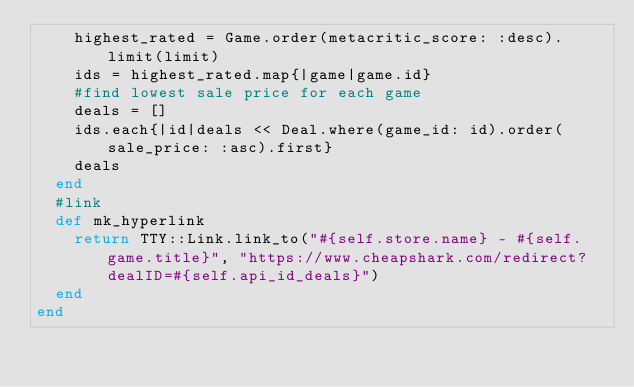Convert code to text. <code><loc_0><loc_0><loc_500><loc_500><_Ruby_>    highest_rated = Game.order(metacritic_score: :desc).limit(limit)
    ids = highest_rated.map{|game|game.id}    
    #find lowest sale price for each game
    deals = []
    ids.each{|id|deals << Deal.where(game_id: id).order(sale_price: :asc).first}  
    deals  
  end
  #link
  def mk_hyperlink
    return TTY::Link.link_to("#{self.store.name} - #{self.game.title}", "https://www.cheapshark.com/redirect?dealID=#{self.api_id_deals}")
  end  
end
</code> 